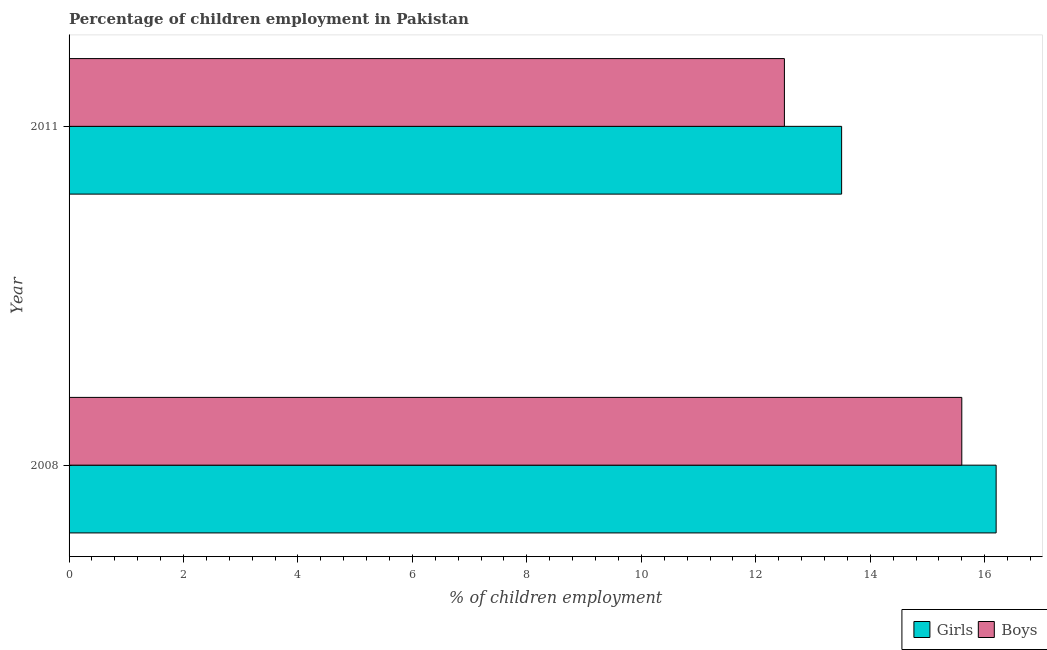Are the number of bars on each tick of the Y-axis equal?
Ensure brevity in your answer.  Yes. How many bars are there on the 1st tick from the top?
Your answer should be very brief. 2. What is the percentage of employed boys in 2011?
Your response must be concise. 12.5. In which year was the percentage of employed girls maximum?
Keep it short and to the point. 2008. What is the total percentage of employed boys in the graph?
Provide a succinct answer. 28.1. What is the difference between the percentage of employed girls in 2008 and the percentage of employed boys in 2011?
Offer a terse response. 3.7. What is the average percentage of employed girls per year?
Your response must be concise. 14.85. In the year 2011, what is the difference between the percentage of employed girls and percentage of employed boys?
Offer a terse response. 1. What is the ratio of the percentage of employed boys in 2008 to that in 2011?
Offer a very short reply. 1.25. Is the percentage of employed boys in 2008 less than that in 2011?
Offer a very short reply. No. What does the 1st bar from the top in 2011 represents?
Ensure brevity in your answer.  Boys. What does the 1st bar from the bottom in 2011 represents?
Offer a very short reply. Girls. How many bars are there?
Your answer should be very brief. 4. How many years are there in the graph?
Provide a succinct answer. 2. What is the difference between two consecutive major ticks on the X-axis?
Provide a succinct answer. 2. Does the graph contain any zero values?
Provide a succinct answer. No. Does the graph contain grids?
Your answer should be very brief. No. How many legend labels are there?
Ensure brevity in your answer.  2. What is the title of the graph?
Make the answer very short. Percentage of children employment in Pakistan. What is the label or title of the X-axis?
Your response must be concise. % of children employment. What is the label or title of the Y-axis?
Your response must be concise. Year. What is the % of children employment of Girls in 2008?
Give a very brief answer. 16.2. Across all years, what is the maximum % of children employment of Girls?
Offer a very short reply. 16.2. Across all years, what is the maximum % of children employment in Boys?
Your answer should be very brief. 15.6. Across all years, what is the minimum % of children employment in Girls?
Offer a very short reply. 13.5. Across all years, what is the minimum % of children employment in Boys?
Offer a terse response. 12.5. What is the total % of children employment in Girls in the graph?
Your answer should be compact. 29.7. What is the total % of children employment of Boys in the graph?
Make the answer very short. 28.1. What is the difference between the % of children employment in Boys in 2008 and that in 2011?
Provide a succinct answer. 3.1. What is the difference between the % of children employment of Girls in 2008 and the % of children employment of Boys in 2011?
Give a very brief answer. 3.7. What is the average % of children employment of Girls per year?
Your answer should be very brief. 14.85. What is the average % of children employment in Boys per year?
Provide a succinct answer. 14.05. What is the ratio of the % of children employment in Girls in 2008 to that in 2011?
Keep it short and to the point. 1.2. What is the ratio of the % of children employment in Boys in 2008 to that in 2011?
Keep it short and to the point. 1.25. What is the difference between the highest and the second highest % of children employment in Girls?
Give a very brief answer. 2.7. What is the difference between the highest and the lowest % of children employment of Boys?
Your answer should be very brief. 3.1. 